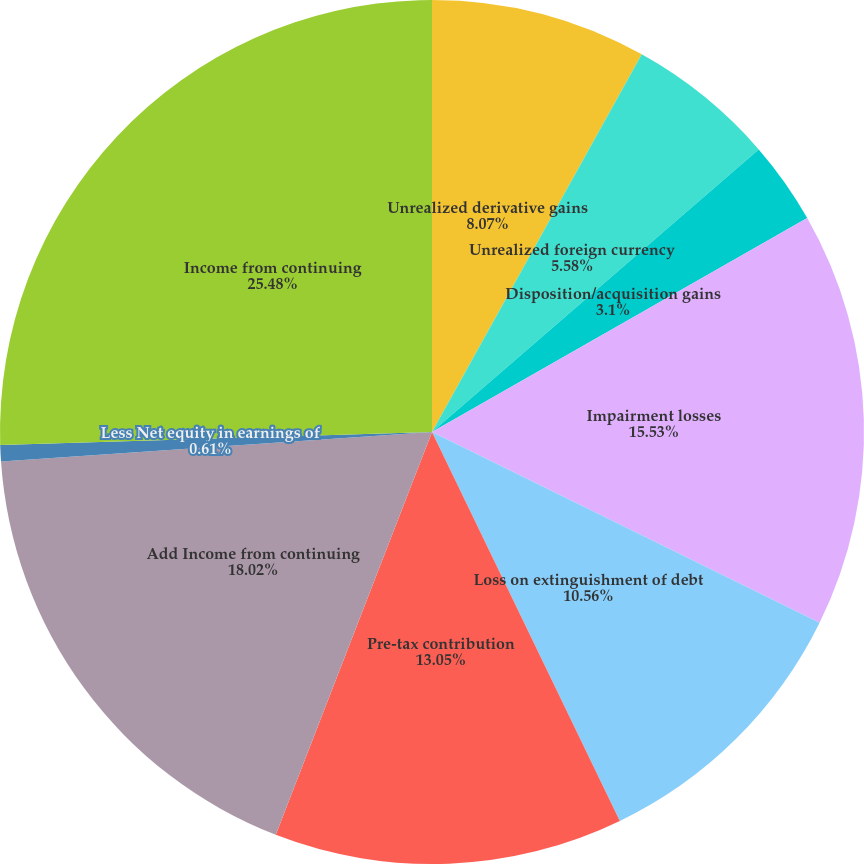<chart> <loc_0><loc_0><loc_500><loc_500><pie_chart><fcel>Unrealized derivative gains<fcel>Unrealized foreign currency<fcel>Disposition/acquisition gains<fcel>Impairment losses<fcel>Loss on extinguishment of debt<fcel>Pre-tax contribution<fcel>Add Income from continuing<fcel>Less Net equity in earnings of<fcel>Income from continuing<nl><fcel>8.07%<fcel>5.58%<fcel>3.1%<fcel>15.53%<fcel>10.56%<fcel>13.05%<fcel>18.02%<fcel>0.61%<fcel>25.48%<nl></chart> 